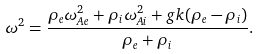Convert formula to latex. <formula><loc_0><loc_0><loc_500><loc_500>\omega ^ { 2 } = \frac { \rho _ { e } \omega _ { A e } ^ { 2 } + \rho _ { i } \omega _ { A i } ^ { 2 } + g k ( \rho _ { e } - \rho _ { i } ) } { \rho _ { e } + \rho _ { i } } .</formula> 